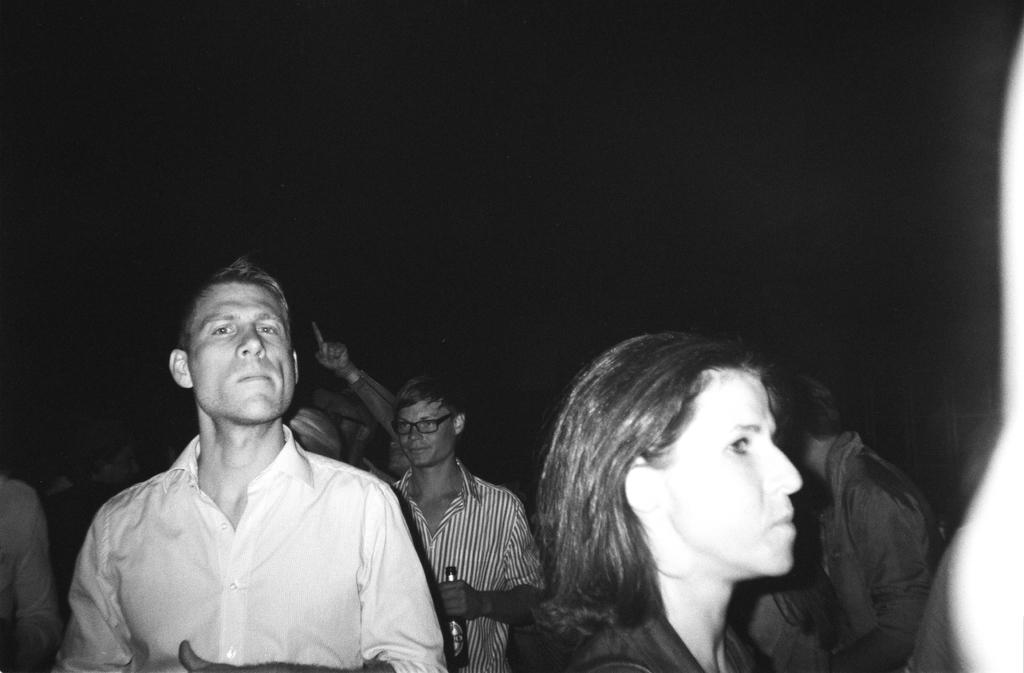What is the color scheme of the image? The image is black and white. Can you describe the people at the bottom of the image? There are people at the bottom of the image, but their specific actions or features are not mentioned in the facts. What is the man holding in his hands? The man is holding a bottle in his hands. How would you describe the overall lighting or brightness of the image? The background of the image is dark. How many trucks can be seen driving through the sea in the image? There are no trucks or sea present in the image; it is a black and white image with people and a man holding a bottle. 